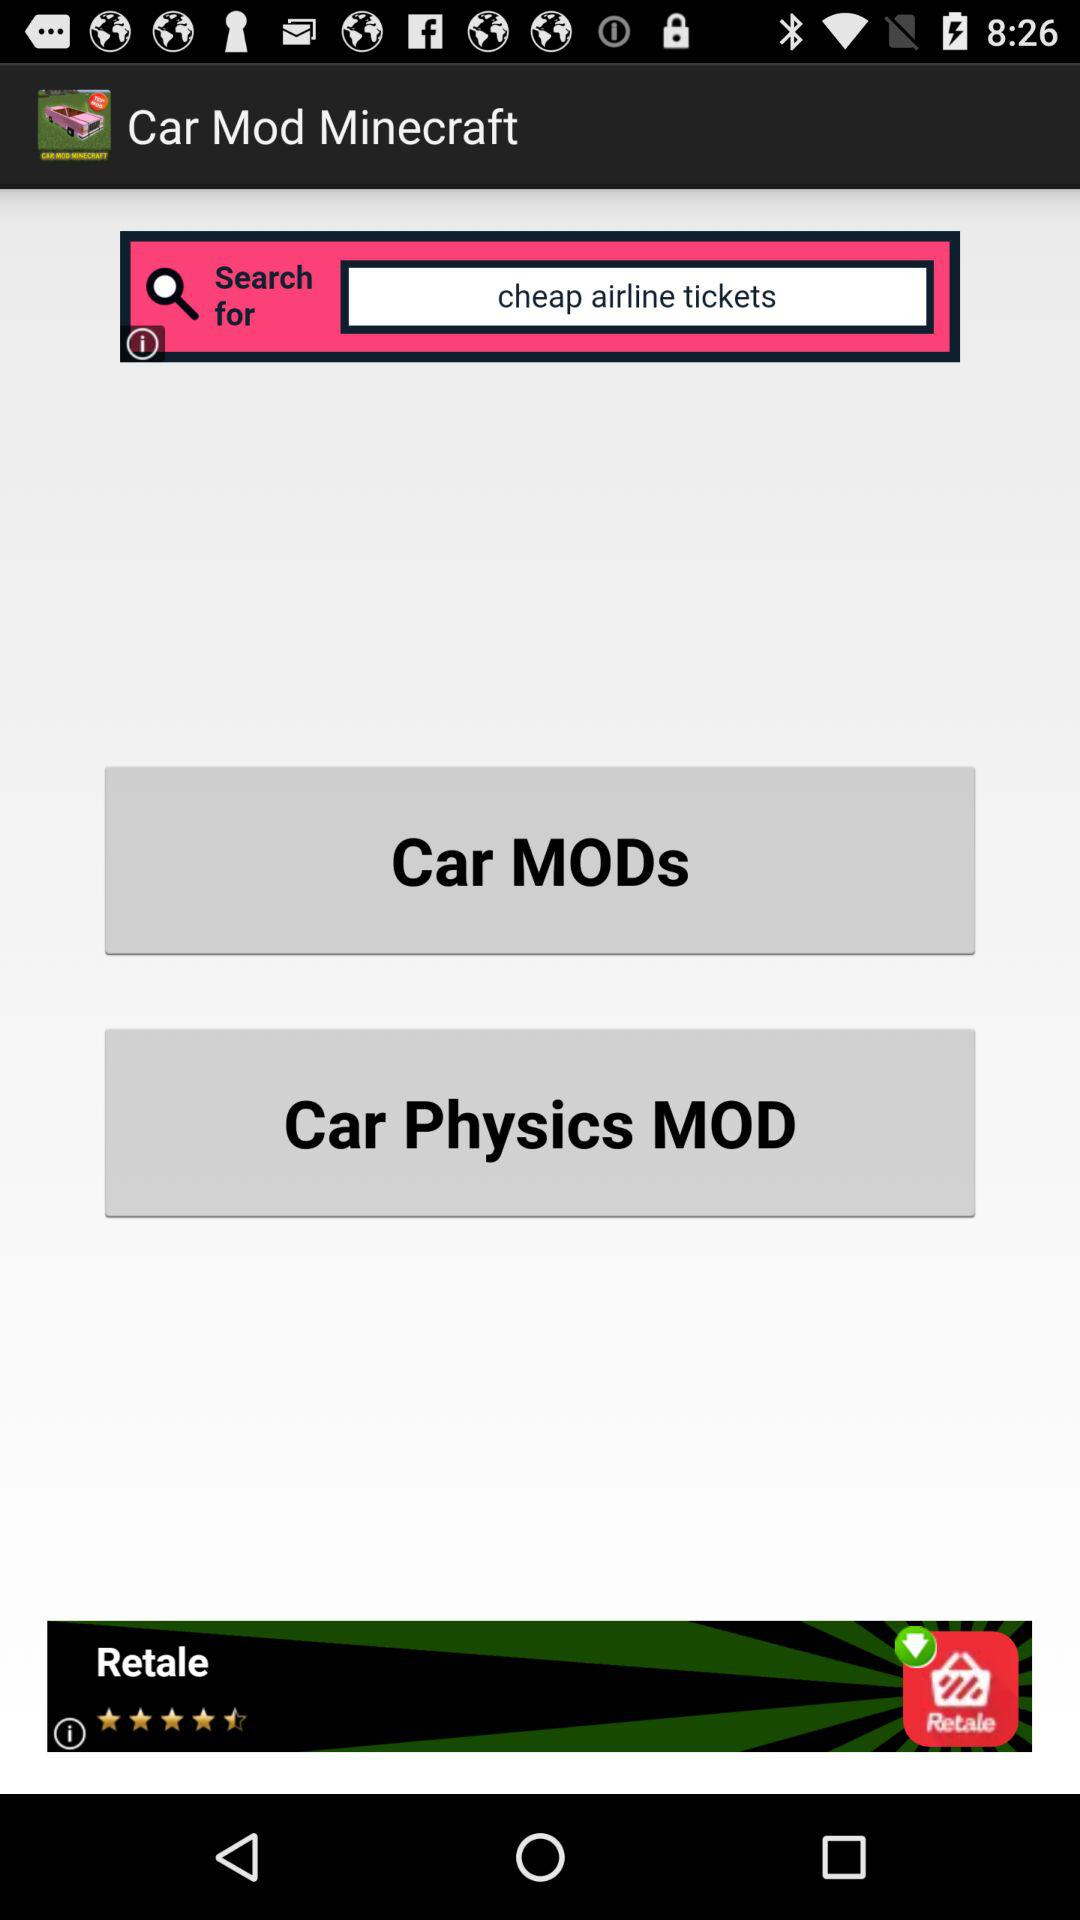How many people reviewed "Retale"?
When the provided information is insufficient, respond with <no answer>. <no answer> 